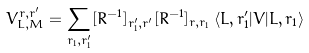<formula> <loc_0><loc_0><loc_500><loc_500>V _ { L , M } ^ { r , r ^ { \prime } } = \sum _ { r _ { 1 } , r _ { 1 } ^ { \prime } } [ R ^ { - 1 } ] _ { r ^ { \prime } _ { 1 } , r ^ { \prime } } [ R ^ { - 1 } ] _ { r , r _ { 1 } } \, \langle L , r ^ { \prime } _ { 1 } | V | L , r _ { 1 } \rangle</formula> 